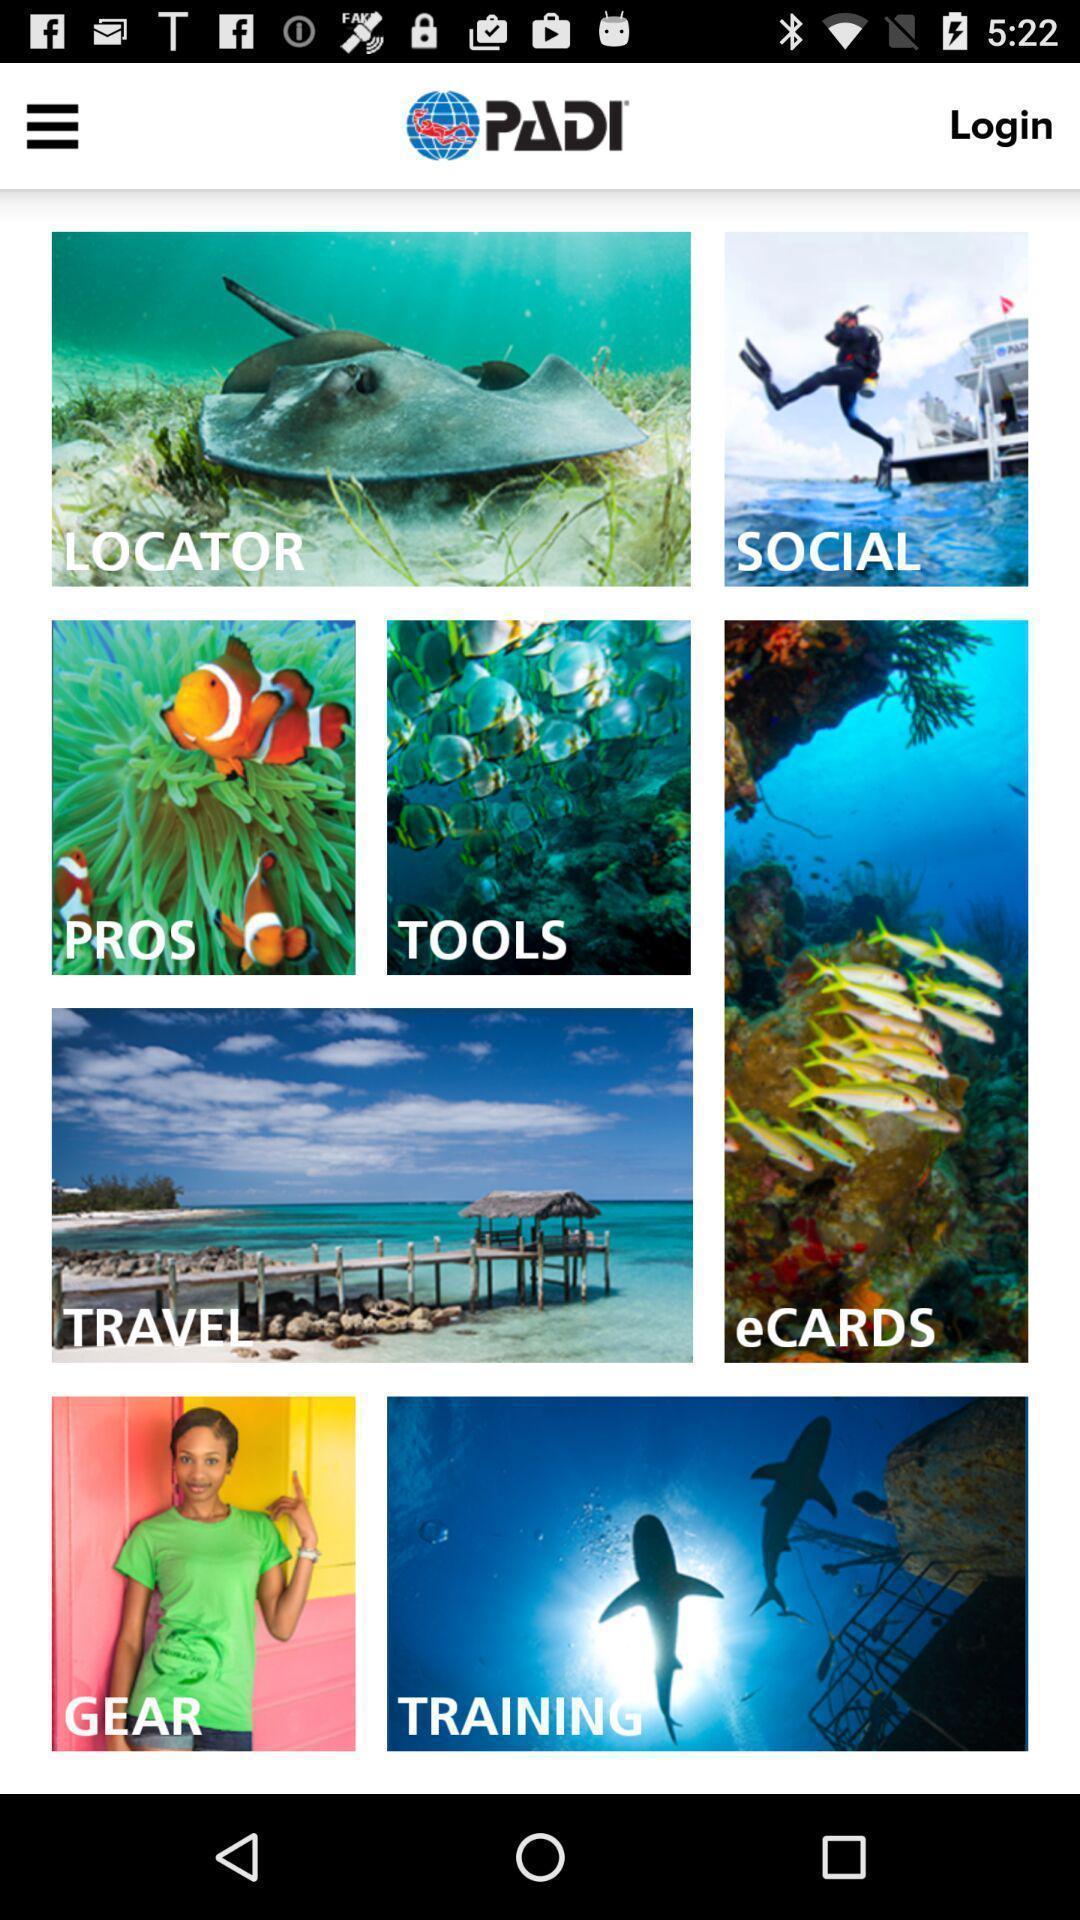Give me a summary of this screen capture. Starting page with many features of a diving app. 